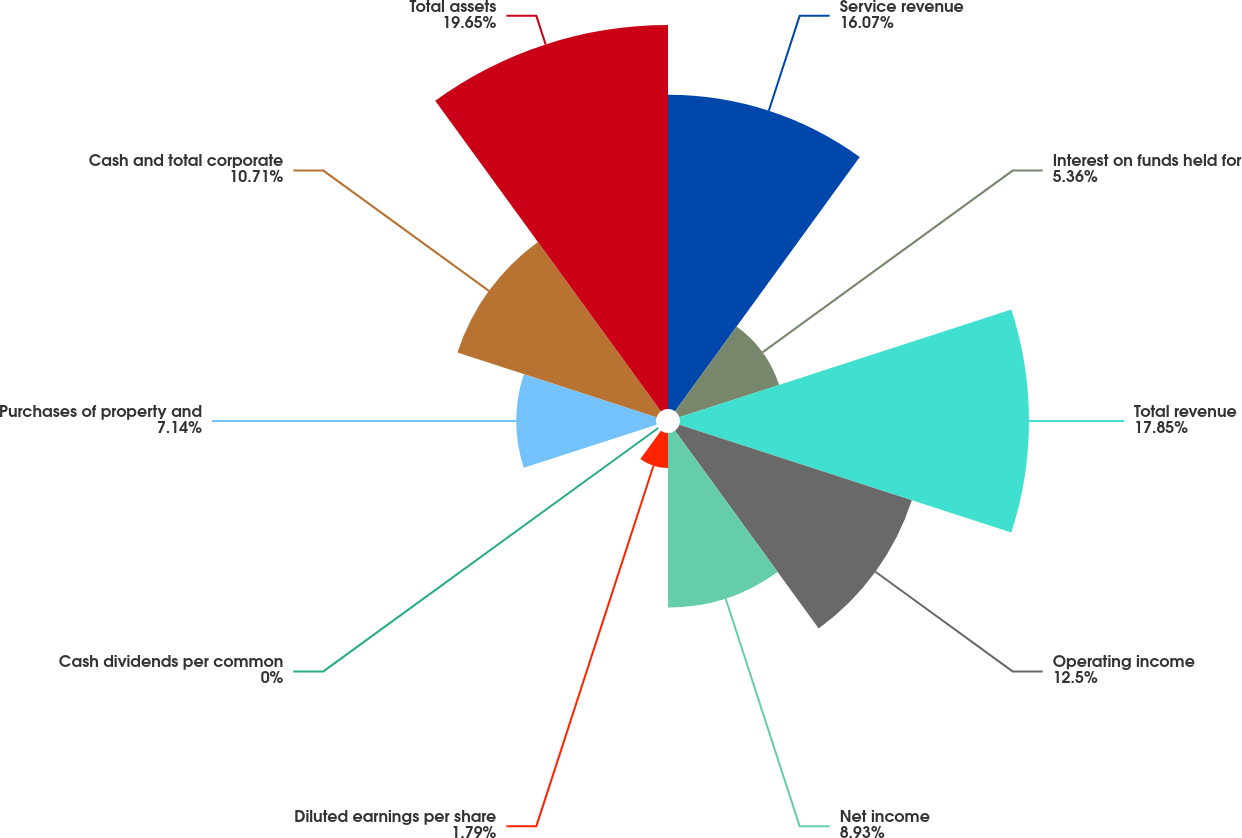Convert chart to OTSL. <chart><loc_0><loc_0><loc_500><loc_500><pie_chart><fcel>Service revenue<fcel>Interest on funds held for<fcel>Total revenue<fcel>Operating income<fcel>Net income<fcel>Diluted earnings per share<fcel>Cash dividends per common<fcel>Purchases of property and<fcel>Cash and total corporate<fcel>Total assets<nl><fcel>16.07%<fcel>5.36%<fcel>17.85%<fcel>12.5%<fcel>8.93%<fcel>1.79%<fcel>0.0%<fcel>7.14%<fcel>10.71%<fcel>19.64%<nl></chart> 